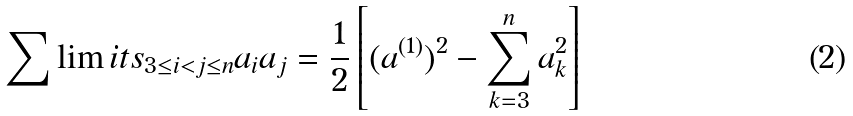Convert formula to latex. <formula><loc_0><loc_0><loc_500><loc_500>\sum \lim i t s _ { 3 \leq i < j \leq n } a _ { i } a _ { j } = \frac { 1 } { 2 } \left [ ( a ^ { ( 1 ) } ) ^ { 2 } - \sum _ { k = 3 } ^ { n } a _ { k } ^ { 2 } \right ]</formula> 